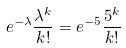<formula> <loc_0><loc_0><loc_500><loc_500>e ^ { - \lambda } \frac { \lambda ^ { k } } { k ! } = e ^ { - 5 } \frac { 5 ^ { k } } { k ! }</formula> 